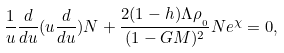Convert formula to latex. <formula><loc_0><loc_0><loc_500><loc_500>\frac { 1 } { u } \frac { d } { d u } ( u \frac { d } { d u } ) N + \frac { 2 ( 1 - h ) \Lambda \rho _ { _ { _ { 0 } } } } { ( 1 - G M ) ^ { 2 } } N e ^ { \chi } = 0 ,</formula> 